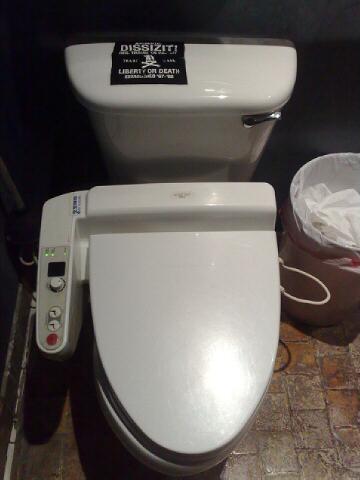How many toilets can be seen?
Give a very brief answer. 1. How many people are holding a tennis racket?
Give a very brief answer. 0. 